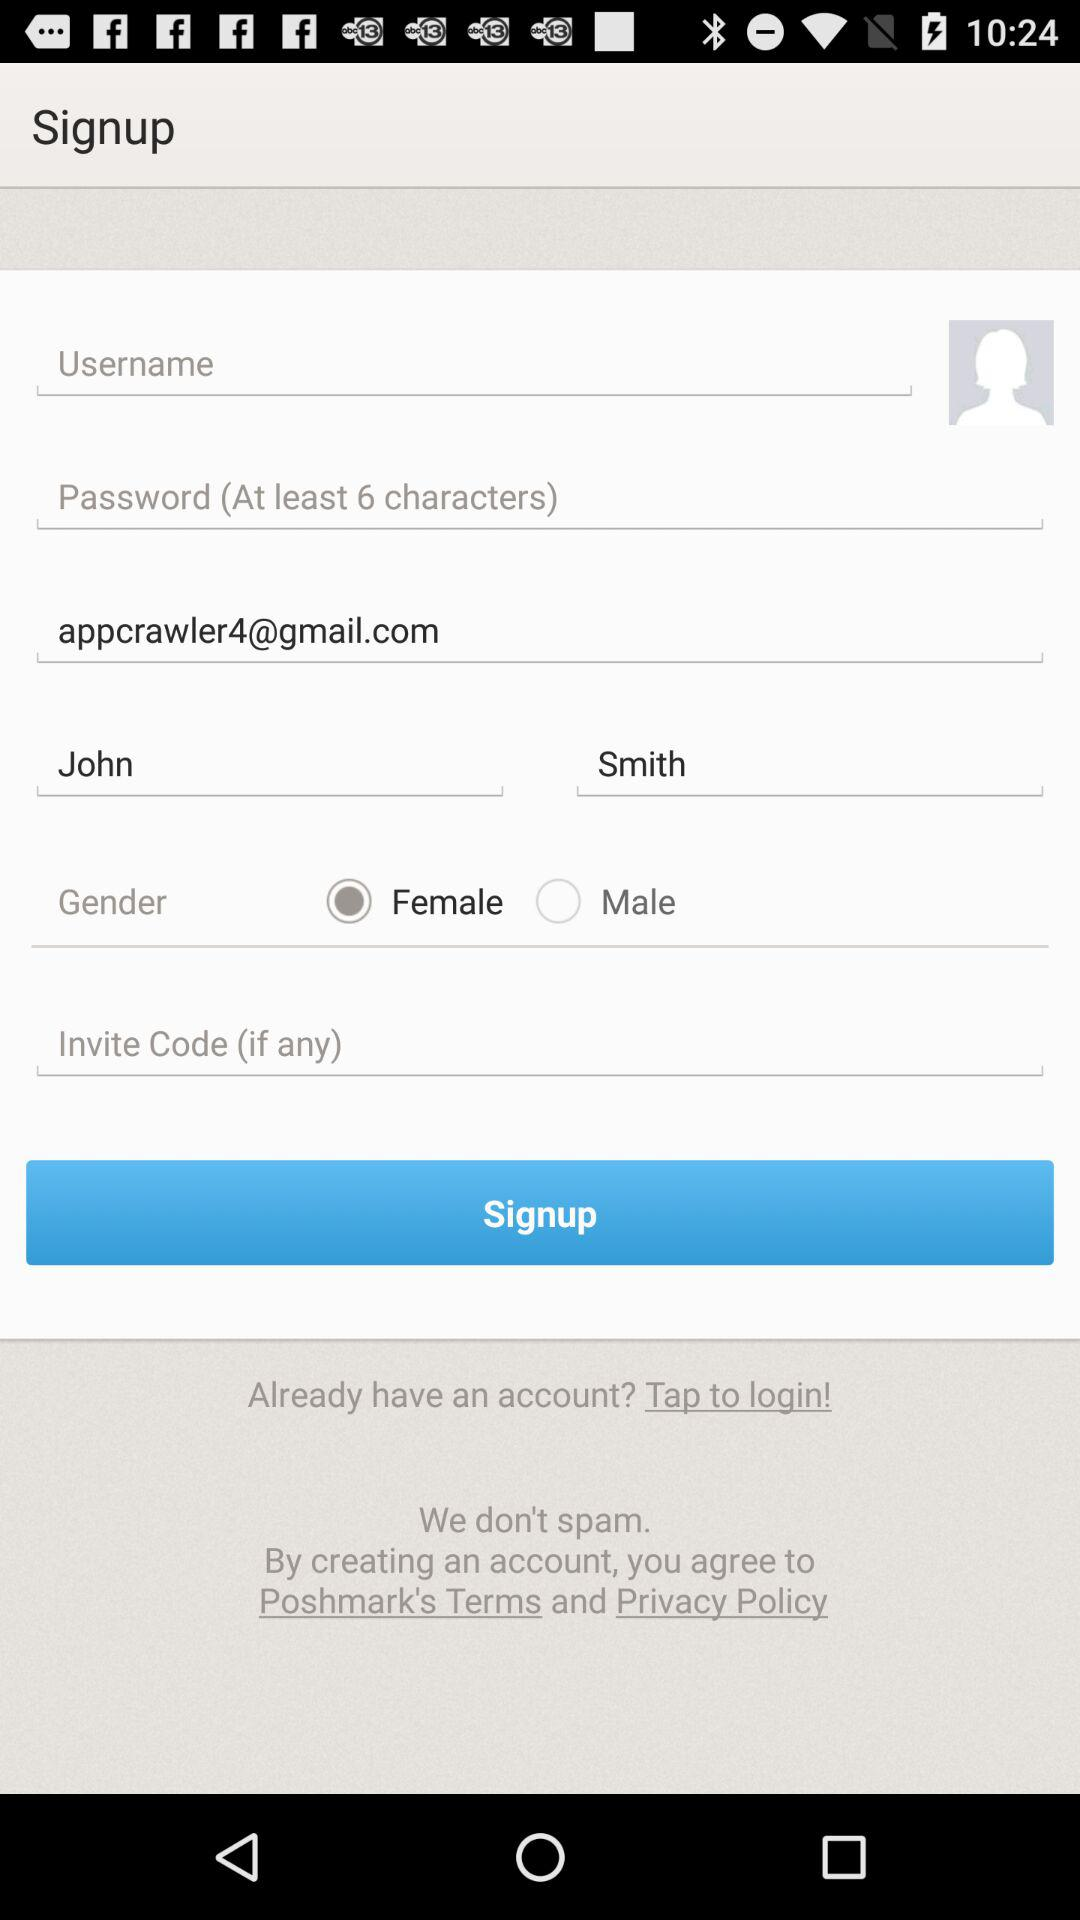What is the gender of the user? The gender of the user is female. 